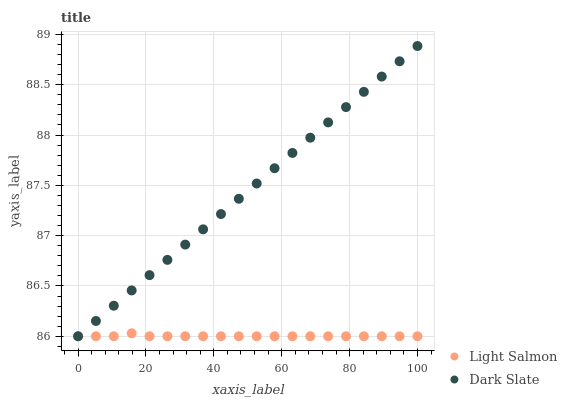Does Light Salmon have the minimum area under the curve?
Answer yes or no. Yes. Does Dark Slate have the maximum area under the curve?
Answer yes or no. Yes. Does Light Salmon have the maximum area under the curve?
Answer yes or no. No. Is Dark Slate the smoothest?
Answer yes or no. Yes. Is Light Salmon the roughest?
Answer yes or no. Yes. Is Light Salmon the smoothest?
Answer yes or no. No. Does Dark Slate have the lowest value?
Answer yes or no. Yes. Does Dark Slate have the highest value?
Answer yes or no. Yes. Does Light Salmon have the highest value?
Answer yes or no. No. Does Dark Slate intersect Light Salmon?
Answer yes or no. Yes. Is Dark Slate less than Light Salmon?
Answer yes or no. No. Is Dark Slate greater than Light Salmon?
Answer yes or no. No. 